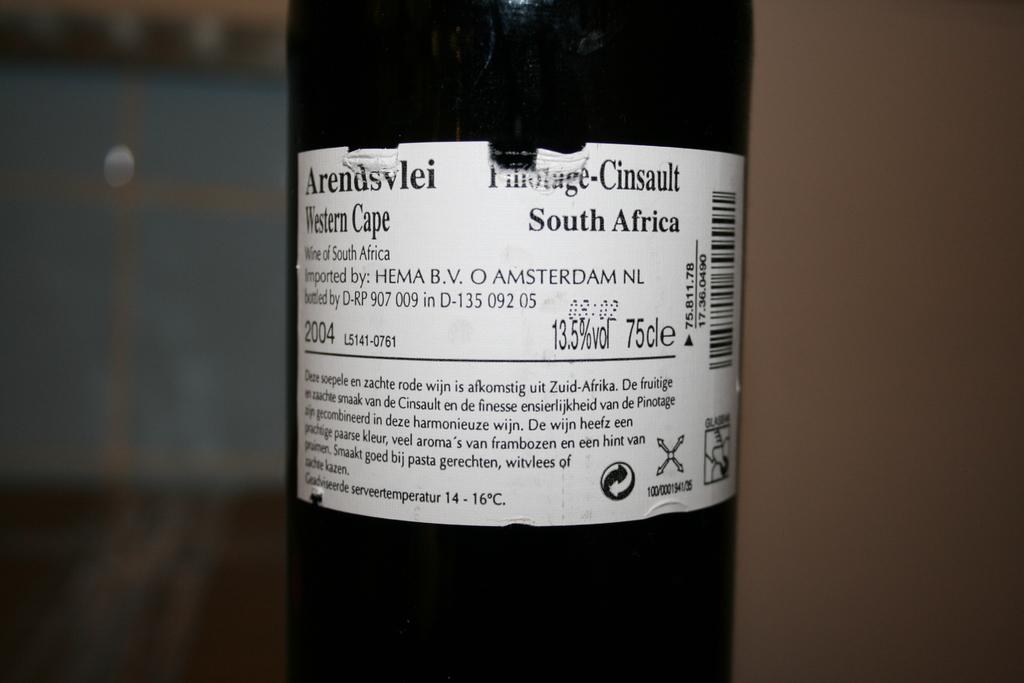<image>
Share a concise interpretation of the image provided. The wine was bottled on the Western Cape of South Africa. 